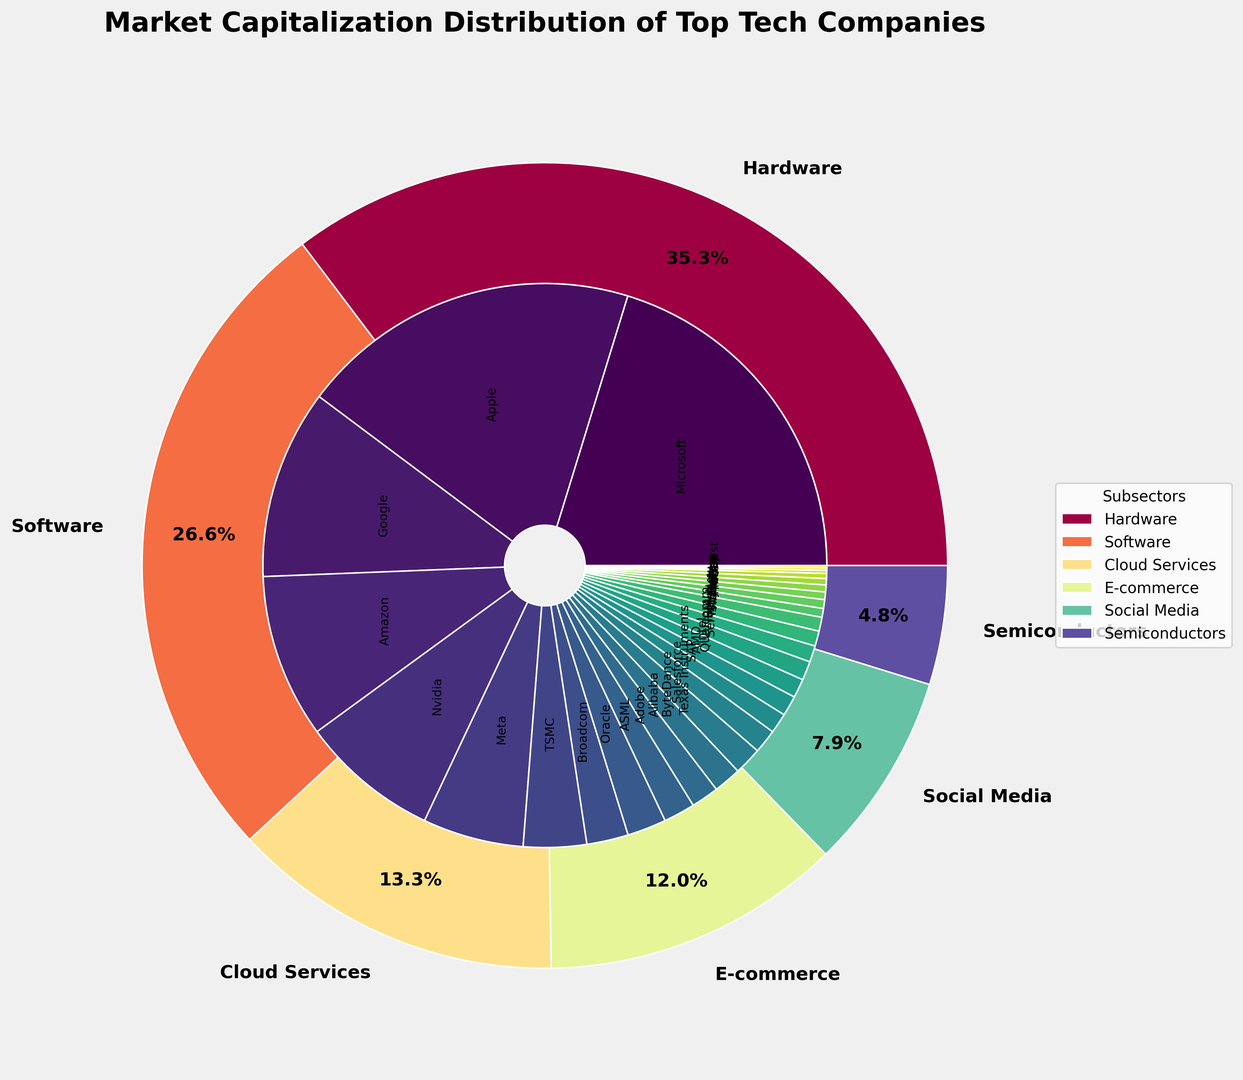What percentage of the overall market capitalization is represented by the Software subsector? First, identify the total market capitalization for the Software subsector by summing the market caps of Microsoft, Oracle, SAP, Adobe, and Salesforce ($2800 + $310 + $160 + $220 + $190 = $3680 billion). Then, sum the market caps of all companies to find the total market capitalization ($2800 + $310 + $160 + $220 + $190 + $2700 + $1100 + $500 + $250 + $330 + $1300 + $220 + $50 + $24 + $70 + $800 + $220 + $40 + $18 + $20 + $1500 + $120 + $55 + $60 + $110 + $150 + $150 + $130 + $160 + $70 = $13977 billion). Finally, divide the Software subsector's market cap by the total market cap and multiply by 100 to get the percentage: ($3680 / $13977) * 100 ≈ 26.4%
Answer: 26.4% Which company in the Hardware subsector has the highest market capitalization, and how much is it? Identify the companies in the Hardware subsector from the data: Apple, Nvidia, TSMC, ASML, and Broadcom. Compare their market caps and identify the highest one, which is Apple with $2700 billion.
Answer: Apple, $2700 billion What is the combined market capitalization of Google and Amazon? Sum the market caps of Google and Amazon. The market cap for Google is $1500 billion, and for Amazon, it is $1300 billion. So the combined market cap is $1500 + $1300 = $2800 billion.
Answer: $2800 billion Does the E-commerce subsector or the Social Media subsector have a larger market capitalization? First, sum the market caps of all companies in the E-commerce subsector: Amazon ($1300), Alibaba ($220), JD.com ($50), eBay ($24), and Shopify ($70) which totals $1664 billion. Then, sum the market caps of all companies in the Social Media subsector: Meta ($800), ByteDance ($220), Twitter ($40), Pinterest ($18), and Snap ($20) which totals $1098 billion. Compare the two sums to determine that E-commerce has a larger market capitalization.
Answer: E-commerce What proportion of the market capitalization in the Semiconductors subsector is accounted for by Intel and AMD combined? Identify the market caps of Intel ($150 billion) and AMD ($150 billion) and sum them up to get $300 billion. Sum the market caps of all companies in the Semiconductors subsector: Intel ($150), AMD ($150), Qualcomm ($130), Texas Instruments ($160), and Micron ($70) which totals $660 billion. Finally, calculate the proportion by dividing the combined market cap of Intel and AMD by the total market cap of the Semiconductors subsector: $300 / $660 ≈ 0.4545 or 45.45%.
Answer: 45.45% What is the smallest market capitalization among all companies, and which company does it belong to? Identify the smallest market cap from the given data, which is $18 billion, and the corresponding company is Pinterest.
Answer: Pinterest, $18 billion How does the market capitalization of Microsoft compare to the combined market cap of TSMC and Nvidia in the Hardware subsector? Identify Microsoft’s market cap ($2800 billion). Then, sum the market caps of TSMC ($500 billion) and Nvidia ($1100 billion) to get $1600 billion. Compare the two values: $2800 billion (Microsoft) is greater than $1600 billion (TSMC and Nvidia combined).
Answer: Microsoft is greater Among the Cloud Services companies, which company has the smallest market capitalization, and what is its value? Identify the companies in the Cloud Services subsector from the data: Google, IBM, VMware, Workday, and ServiceNow. Compare their market caps and find the smallest one, which is VMware with a market cap of $55 billion.
Answer: VMware, $55 billion 